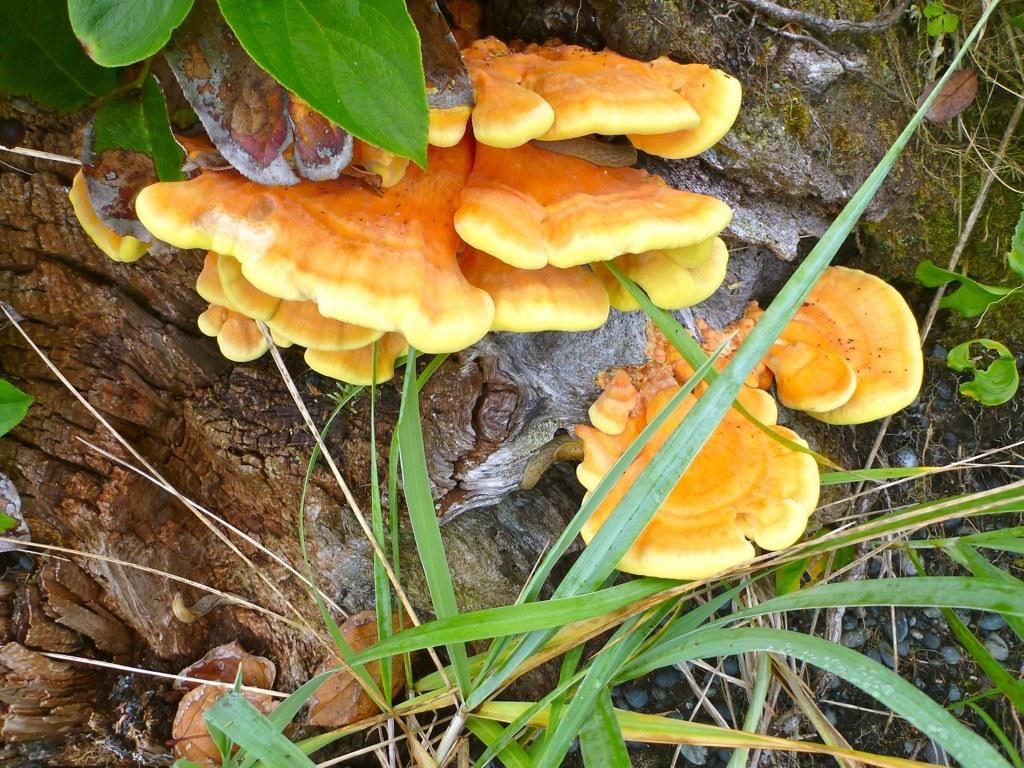What type of vegetation can be seen in the image? There is a tree and plants in the image. What other object can be seen in the image? There appears to be a mushroom in the image. What is present at the bottom of the image? Pebbles and mud are present at the bottom of the image. How many babies are present in the image? There are no babies present in the image. What type of family can be seen in the image? There is no family depicted in the image; it features a tree, plants, a mushroom, pebbles, and mud. 